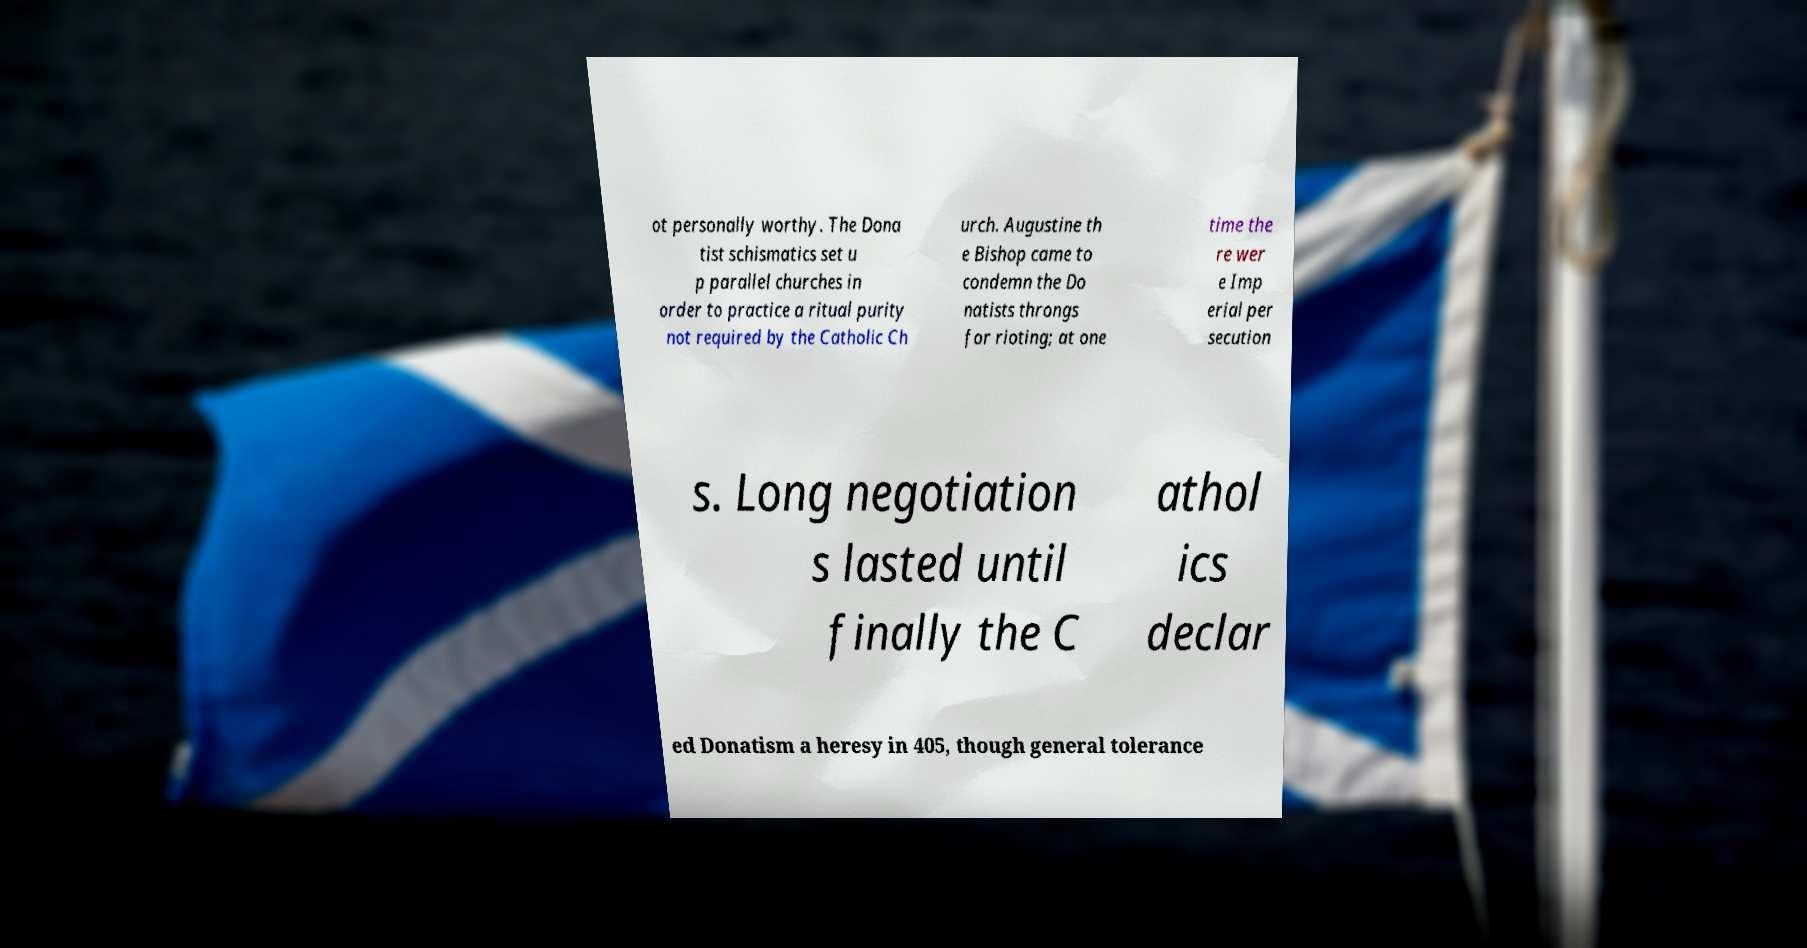Can you read and provide the text displayed in the image?This photo seems to have some interesting text. Can you extract and type it out for me? ot personally worthy. The Dona tist schismatics set u p parallel churches in order to practice a ritual purity not required by the Catholic Ch urch. Augustine th e Bishop came to condemn the Do natists throngs for rioting; at one time the re wer e Imp erial per secution s. Long negotiation s lasted until finally the C athol ics declar ed Donatism a heresy in 405, though general tolerance 